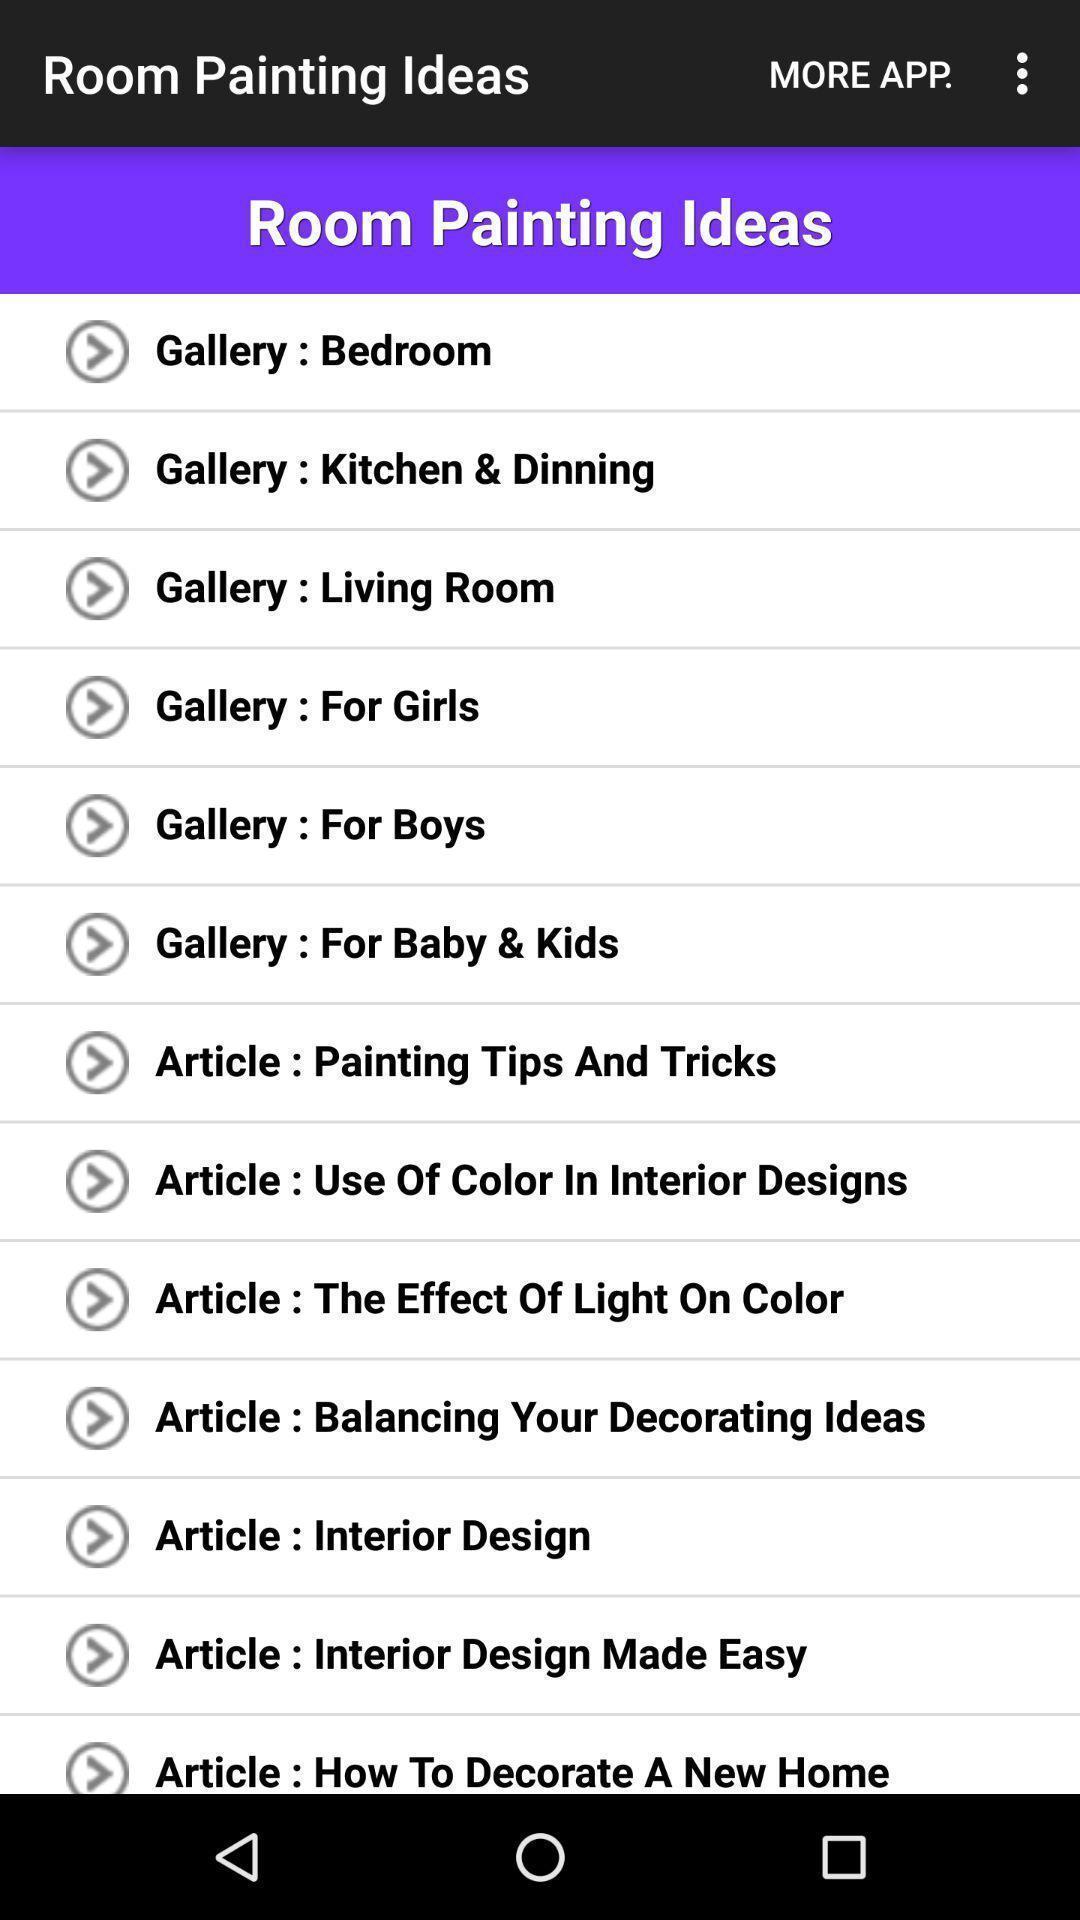Describe this image in words. Page displaying options in room designing ideas app. 